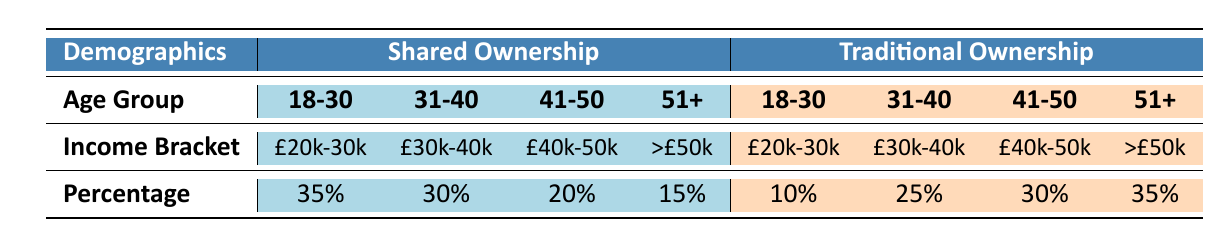What percentage of buyers in Shared Ownership are aged 18-30? The table shows that for Shared Ownership, the percentage of buyers in the 18-30 age group is 35%.
Answer: 35% How many percentage points more of Shared Ownership buyers earn between £30,001 and £40,000 compared to Traditional Ownership buyers in the same income bracket? From the table, 30% of Shared Ownership buyers earn between £30,001 and £40,000, while 25% of Traditional Ownership buyers do. The difference is 30% - 25% = 5 percentage points.
Answer: 5 Is the percentage of buyers aged 51 and older in Traditional Ownership higher than in Shared Ownership? For Traditional Ownership, the percentage of buyers aged 51 and older is 35%, while in Shared Ownership it is 15%. Since 35% is greater than 15%, the answer is yes.
Answer: Yes What is the total percentage of Shared Ownership buyers across all age groups that earn above £50,000? Only the 51+ age group in Shared Ownership earns above £50,000, which constitutes 15%. Therefore, the total from Shared Ownership for this income bracket is 15%.
Answer: 15% If we combine the percentage of Shared Ownership buyers aged 41-50 with those aged 51+, what percentage do they represent together? In the Shared Ownership category, the percentage of buyers aged 41-50 is 20% and those aged 51+ is 15%. Adding these, we have 20% + 15% = 35%.
Answer: 35% How many more percentage points do Shared Ownership buyers in the age group of 31-40 represent compared to Traditional Ownership buyers of the same age group? The table indicates that 30% of Shared Ownership buyers and 25% of Traditional Ownership buyers are aged 31-40. The difference is 30% - 25% = 5 percentage points.
Answer: 5 What income bracket has the largest percentage of buyers in Shared Ownership? Among the income brackets for Shared Ownership, the £20,000 - £30,000 category has the highest percentage at 35%.
Answer: £20,000 - £30,000 Are there more Shared Ownership buyers aged 18-30 than Traditional Ownership buyers in the same age group? The table shows 35% for Shared Ownership and 10% for Traditional Ownership in the 18-30 age group. Since 35% is greater than 10%, the answer is yes.
Answer: Yes What is the combined percentage of buyers aged 41-50 in both ownership types? In Shared Ownership, the percentage for the 41-50 age bracket is 20%, and for Traditional Ownership, it is 30%. The combined percentage is 20% + 30% = 50%.
Answer: 50% 